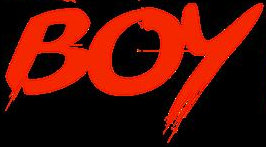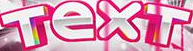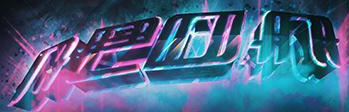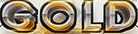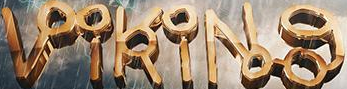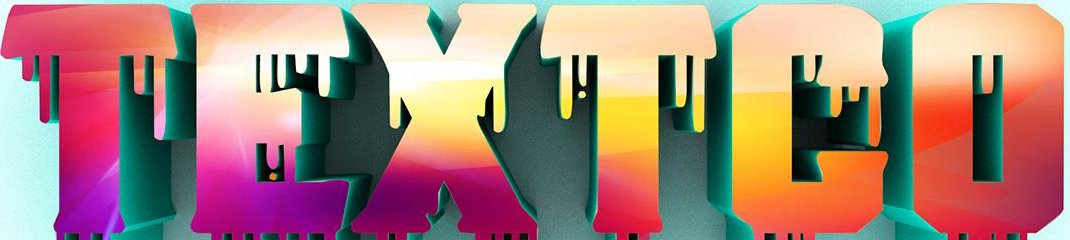Read the text from these images in sequence, separated by a semicolon. BOY; TexT; neon; GOLD; VikiNg; TEXTCO 